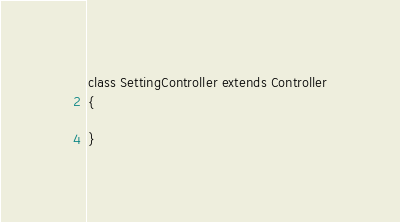Convert code to text. <code><loc_0><loc_0><loc_500><loc_500><_PHP_>class SettingController extends Controller
{
    
}
</code> 